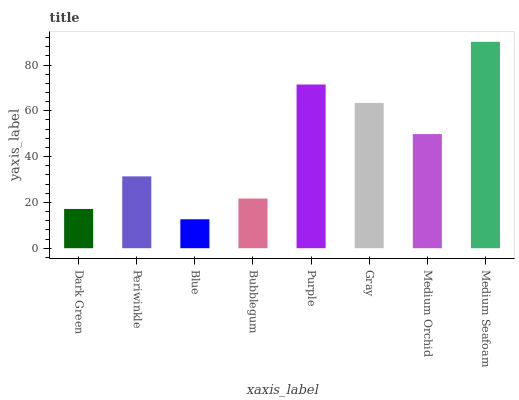Is Blue the minimum?
Answer yes or no. Yes. Is Medium Seafoam the maximum?
Answer yes or no. Yes. Is Periwinkle the minimum?
Answer yes or no. No. Is Periwinkle the maximum?
Answer yes or no. No. Is Periwinkle greater than Dark Green?
Answer yes or no. Yes. Is Dark Green less than Periwinkle?
Answer yes or no. Yes. Is Dark Green greater than Periwinkle?
Answer yes or no. No. Is Periwinkle less than Dark Green?
Answer yes or no. No. Is Medium Orchid the high median?
Answer yes or no. Yes. Is Periwinkle the low median?
Answer yes or no. Yes. Is Periwinkle the high median?
Answer yes or no. No. Is Medium Seafoam the low median?
Answer yes or no. No. 